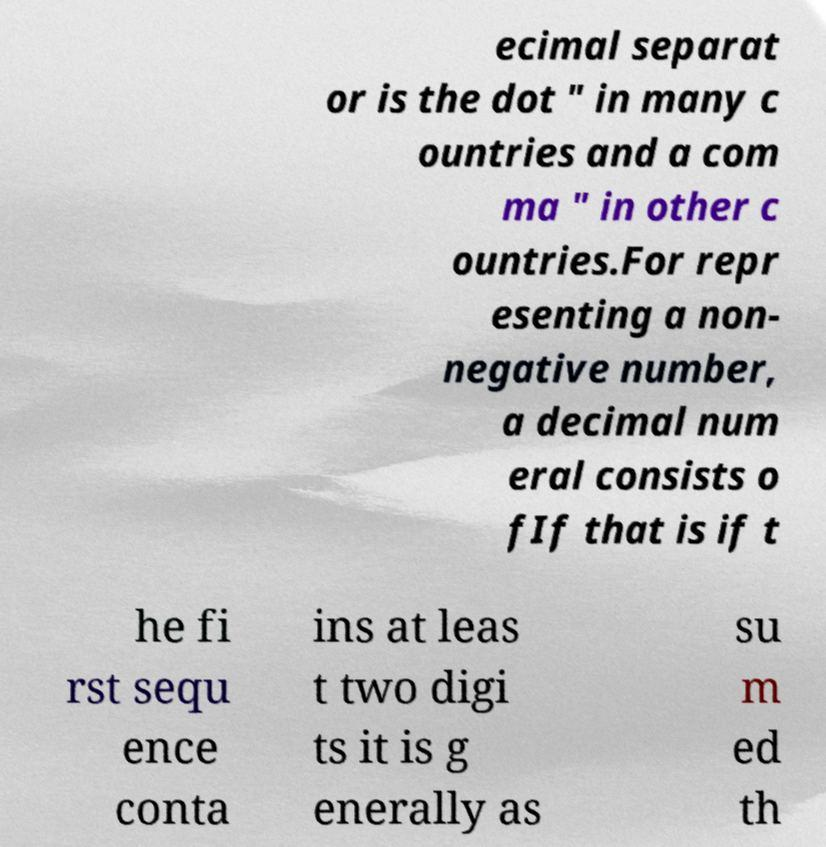For documentation purposes, I need the text within this image transcribed. Could you provide that? ecimal separat or is the dot " in many c ountries and a com ma " in other c ountries.For repr esenting a non- negative number, a decimal num eral consists o fIf that is if t he fi rst sequ ence conta ins at leas t two digi ts it is g enerally as su m ed th 